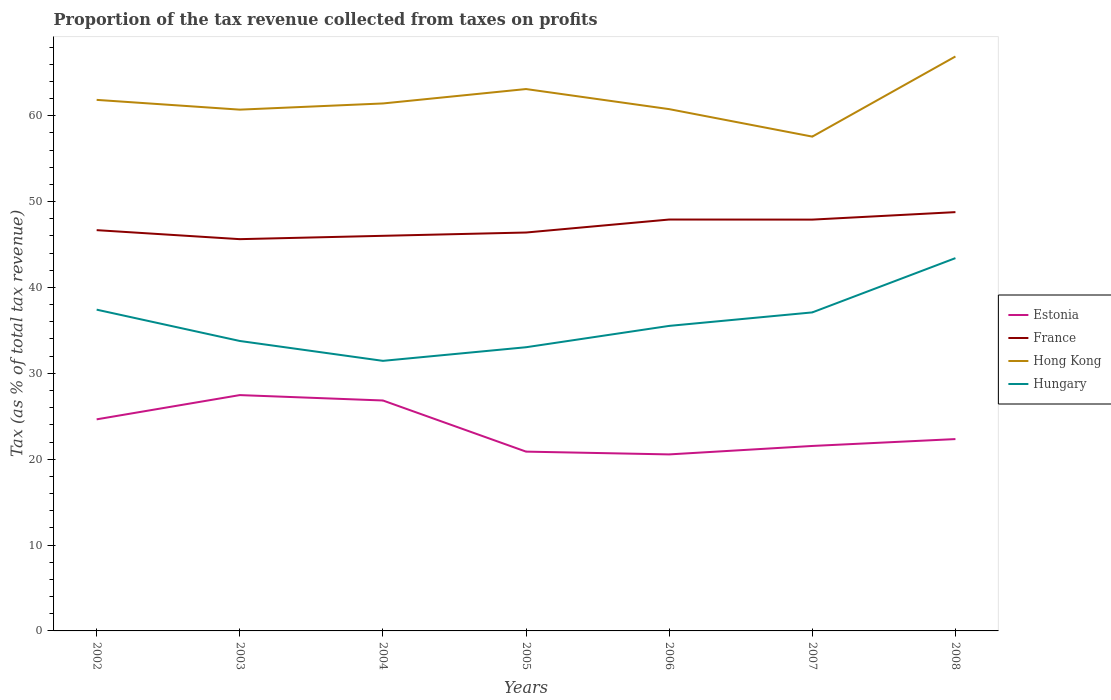How many different coloured lines are there?
Your response must be concise. 4. Across all years, what is the maximum proportion of the tax revenue collected in France?
Ensure brevity in your answer.  45.63. What is the total proportion of the tax revenue collected in Estonia in the graph?
Keep it short and to the point. 5.92. What is the difference between the highest and the second highest proportion of the tax revenue collected in Hungary?
Offer a very short reply. 11.96. Is the proportion of the tax revenue collected in Hungary strictly greater than the proportion of the tax revenue collected in France over the years?
Offer a very short reply. Yes. What is the difference between two consecutive major ticks on the Y-axis?
Provide a succinct answer. 10. Are the values on the major ticks of Y-axis written in scientific E-notation?
Make the answer very short. No. Does the graph contain any zero values?
Provide a succinct answer. No. Does the graph contain grids?
Offer a very short reply. No. Where does the legend appear in the graph?
Offer a terse response. Center right. How many legend labels are there?
Your answer should be very brief. 4. What is the title of the graph?
Your response must be concise. Proportion of the tax revenue collected from taxes on profits. Does "Ukraine" appear as one of the legend labels in the graph?
Offer a very short reply. No. What is the label or title of the X-axis?
Provide a short and direct response. Years. What is the label or title of the Y-axis?
Provide a succinct answer. Tax (as % of total tax revenue). What is the Tax (as % of total tax revenue) in Estonia in 2002?
Provide a succinct answer. 24.64. What is the Tax (as % of total tax revenue) in France in 2002?
Offer a very short reply. 46.68. What is the Tax (as % of total tax revenue) of Hong Kong in 2002?
Offer a terse response. 61.85. What is the Tax (as % of total tax revenue) in Hungary in 2002?
Your answer should be very brief. 37.42. What is the Tax (as % of total tax revenue) in Estonia in 2003?
Your answer should be very brief. 27.47. What is the Tax (as % of total tax revenue) in France in 2003?
Provide a short and direct response. 45.63. What is the Tax (as % of total tax revenue) of Hong Kong in 2003?
Provide a succinct answer. 60.71. What is the Tax (as % of total tax revenue) in Hungary in 2003?
Your answer should be compact. 33.77. What is the Tax (as % of total tax revenue) in Estonia in 2004?
Make the answer very short. 26.84. What is the Tax (as % of total tax revenue) of France in 2004?
Keep it short and to the point. 46.02. What is the Tax (as % of total tax revenue) in Hong Kong in 2004?
Your answer should be compact. 61.43. What is the Tax (as % of total tax revenue) in Hungary in 2004?
Ensure brevity in your answer.  31.45. What is the Tax (as % of total tax revenue) of Estonia in 2005?
Keep it short and to the point. 20.88. What is the Tax (as % of total tax revenue) of France in 2005?
Provide a short and direct response. 46.4. What is the Tax (as % of total tax revenue) in Hong Kong in 2005?
Provide a short and direct response. 63.11. What is the Tax (as % of total tax revenue) in Hungary in 2005?
Provide a short and direct response. 33.04. What is the Tax (as % of total tax revenue) of Estonia in 2006?
Offer a very short reply. 20.56. What is the Tax (as % of total tax revenue) of France in 2006?
Offer a very short reply. 47.91. What is the Tax (as % of total tax revenue) of Hong Kong in 2006?
Make the answer very short. 60.77. What is the Tax (as % of total tax revenue) in Hungary in 2006?
Your response must be concise. 35.53. What is the Tax (as % of total tax revenue) of Estonia in 2007?
Provide a succinct answer. 21.54. What is the Tax (as % of total tax revenue) of France in 2007?
Your answer should be compact. 47.9. What is the Tax (as % of total tax revenue) of Hong Kong in 2007?
Offer a terse response. 57.57. What is the Tax (as % of total tax revenue) of Hungary in 2007?
Offer a terse response. 37.1. What is the Tax (as % of total tax revenue) of Estonia in 2008?
Keep it short and to the point. 22.34. What is the Tax (as % of total tax revenue) of France in 2008?
Make the answer very short. 48.78. What is the Tax (as % of total tax revenue) of Hong Kong in 2008?
Offer a very short reply. 66.9. What is the Tax (as % of total tax revenue) in Hungary in 2008?
Provide a succinct answer. 43.42. Across all years, what is the maximum Tax (as % of total tax revenue) of Estonia?
Provide a succinct answer. 27.47. Across all years, what is the maximum Tax (as % of total tax revenue) in France?
Give a very brief answer. 48.78. Across all years, what is the maximum Tax (as % of total tax revenue) in Hong Kong?
Give a very brief answer. 66.9. Across all years, what is the maximum Tax (as % of total tax revenue) in Hungary?
Your response must be concise. 43.42. Across all years, what is the minimum Tax (as % of total tax revenue) in Estonia?
Your answer should be very brief. 20.56. Across all years, what is the minimum Tax (as % of total tax revenue) in France?
Keep it short and to the point. 45.63. Across all years, what is the minimum Tax (as % of total tax revenue) in Hong Kong?
Give a very brief answer. 57.57. Across all years, what is the minimum Tax (as % of total tax revenue) of Hungary?
Give a very brief answer. 31.45. What is the total Tax (as % of total tax revenue) in Estonia in the graph?
Make the answer very short. 164.27. What is the total Tax (as % of total tax revenue) of France in the graph?
Keep it short and to the point. 329.31. What is the total Tax (as % of total tax revenue) of Hong Kong in the graph?
Offer a terse response. 432.34. What is the total Tax (as % of total tax revenue) in Hungary in the graph?
Keep it short and to the point. 251.72. What is the difference between the Tax (as % of total tax revenue) in Estonia in 2002 and that in 2003?
Provide a succinct answer. -2.82. What is the difference between the Tax (as % of total tax revenue) of France in 2002 and that in 2003?
Provide a short and direct response. 1.05. What is the difference between the Tax (as % of total tax revenue) in Hong Kong in 2002 and that in 2003?
Make the answer very short. 1.14. What is the difference between the Tax (as % of total tax revenue) in Hungary in 2002 and that in 2003?
Ensure brevity in your answer.  3.65. What is the difference between the Tax (as % of total tax revenue) in Estonia in 2002 and that in 2004?
Provide a short and direct response. -2.2. What is the difference between the Tax (as % of total tax revenue) in France in 2002 and that in 2004?
Provide a short and direct response. 0.66. What is the difference between the Tax (as % of total tax revenue) of Hong Kong in 2002 and that in 2004?
Your answer should be very brief. 0.42. What is the difference between the Tax (as % of total tax revenue) in Hungary in 2002 and that in 2004?
Your response must be concise. 5.96. What is the difference between the Tax (as % of total tax revenue) of Estonia in 2002 and that in 2005?
Make the answer very short. 3.76. What is the difference between the Tax (as % of total tax revenue) of France in 2002 and that in 2005?
Give a very brief answer. 0.28. What is the difference between the Tax (as % of total tax revenue) of Hong Kong in 2002 and that in 2005?
Your answer should be very brief. -1.26. What is the difference between the Tax (as % of total tax revenue) of Hungary in 2002 and that in 2005?
Offer a terse response. 4.38. What is the difference between the Tax (as % of total tax revenue) in Estonia in 2002 and that in 2006?
Give a very brief answer. 4.08. What is the difference between the Tax (as % of total tax revenue) of France in 2002 and that in 2006?
Offer a terse response. -1.24. What is the difference between the Tax (as % of total tax revenue) in Hong Kong in 2002 and that in 2006?
Your answer should be very brief. 1.08. What is the difference between the Tax (as % of total tax revenue) in Hungary in 2002 and that in 2006?
Your response must be concise. 1.89. What is the difference between the Tax (as % of total tax revenue) in Estonia in 2002 and that in 2007?
Keep it short and to the point. 3.1. What is the difference between the Tax (as % of total tax revenue) in France in 2002 and that in 2007?
Offer a very short reply. -1.23. What is the difference between the Tax (as % of total tax revenue) in Hong Kong in 2002 and that in 2007?
Provide a short and direct response. 4.28. What is the difference between the Tax (as % of total tax revenue) of Hungary in 2002 and that in 2007?
Ensure brevity in your answer.  0.32. What is the difference between the Tax (as % of total tax revenue) of Estonia in 2002 and that in 2008?
Provide a short and direct response. 2.3. What is the difference between the Tax (as % of total tax revenue) of France in 2002 and that in 2008?
Offer a very short reply. -2.1. What is the difference between the Tax (as % of total tax revenue) of Hong Kong in 2002 and that in 2008?
Offer a terse response. -5.05. What is the difference between the Tax (as % of total tax revenue) of Hungary in 2002 and that in 2008?
Make the answer very short. -6. What is the difference between the Tax (as % of total tax revenue) in Estonia in 2003 and that in 2004?
Keep it short and to the point. 0.63. What is the difference between the Tax (as % of total tax revenue) of France in 2003 and that in 2004?
Offer a very short reply. -0.39. What is the difference between the Tax (as % of total tax revenue) in Hong Kong in 2003 and that in 2004?
Make the answer very short. -0.72. What is the difference between the Tax (as % of total tax revenue) in Hungary in 2003 and that in 2004?
Offer a very short reply. 2.32. What is the difference between the Tax (as % of total tax revenue) in Estonia in 2003 and that in 2005?
Ensure brevity in your answer.  6.58. What is the difference between the Tax (as % of total tax revenue) in France in 2003 and that in 2005?
Give a very brief answer. -0.77. What is the difference between the Tax (as % of total tax revenue) of Hong Kong in 2003 and that in 2005?
Ensure brevity in your answer.  -2.4. What is the difference between the Tax (as % of total tax revenue) in Hungary in 2003 and that in 2005?
Provide a short and direct response. 0.73. What is the difference between the Tax (as % of total tax revenue) in Estonia in 2003 and that in 2006?
Offer a terse response. 6.91. What is the difference between the Tax (as % of total tax revenue) in France in 2003 and that in 2006?
Your answer should be very brief. -2.29. What is the difference between the Tax (as % of total tax revenue) in Hong Kong in 2003 and that in 2006?
Provide a succinct answer. -0.06. What is the difference between the Tax (as % of total tax revenue) of Hungary in 2003 and that in 2006?
Ensure brevity in your answer.  -1.76. What is the difference between the Tax (as % of total tax revenue) in Estonia in 2003 and that in 2007?
Your answer should be compact. 5.92. What is the difference between the Tax (as % of total tax revenue) of France in 2003 and that in 2007?
Offer a terse response. -2.28. What is the difference between the Tax (as % of total tax revenue) of Hong Kong in 2003 and that in 2007?
Your response must be concise. 3.14. What is the difference between the Tax (as % of total tax revenue) in Hungary in 2003 and that in 2007?
Make the answer very short. -3.33. What is the difference between the Tax (as % of total tax revenue) in Estonia in 2003 and that in 2008?
Ensure brevity in your answer.  5.12. What is the difference between the Tax (as % of total tax revenue) of France in 2003 and that in 2008?
Make the answer very short. -3.15. What is the difference between the Tax (as % of total tax revenue) of Hong Kong in 2003 and that in 2008?
Make the answer very short. -6.19. What is the difference between the Tax (as % of total tax revenue) in Hungary in 2003 and that in 2008?
Provide a succinct answer. -9.65. What is the difference between the Tax (as % of total tax revenue) in Estonia in 2004 and that in 2005?
Your answer should be very brief. 5.96. What is the difference between the Tax (as % of total tax revenue) in France in 2004 and that in 2005?
Offer a very short reply. -0.38. What is the difference between the Tax (as % of total tax revenue) of Hong Kong in 2004 and that in 2005?
Your answer should be compact. -1.68. What is the difference between the Tax (as % of total tax revenue) in Hungary in 2004 and that in 2005?
Keep it short and to the point. -1.59. What is the difference between the Tax (as % of total tax revenue) of Estonia in 2004 and that in 2006?
Offer a very short reply. 6.28. What is the difference between the Tax (as % of total tax revenue) of France in 2004 and that in 2006?
Provide a succinct answer. -1.9. What is the difference between the Tax (as % of total tax revenue) in Hong Kong in 2004 and that in 2006?
Give a very brief answer. 0.66. What is the difference between the Tax (as % of total tax revenue) in Hungary in 2004 and that in 2006?
Provide a short and direct response. -4.07. What is the difference between the Tax (as % of total tax revenue) in Estonia in 2004 and that in 2007?
Provide a succinct answer. 5.3. What is the difference between the Tax (as % of total tax revenue) of France in 2004 and that in 2007?
Your answer should be compact. -1.89. What is the difference between the Tax (as % of total tax revenue) in Hong Kong in 2004 and that in 2007?
Offer a very short reply. 3.86. What is the difference between the Tax (as % of total tax revenue) of Hungary in 2004 and that in 2007?
Make the answer very short. -5.64. What is the difference between the Tax (as % of total tax revenue) of Estonia in 2004 and that in 2008?
Your answer should be very brief. 4.5. What is the difference between the Tax (as % of total tax revenue) in France in 2004 and that in 2008?
Offer a very short reply. -2.76. What is the difference between the Tax (as % of total tax revenue) of Hong Kong in 2004 and that in 2008?
Your answer should be compact. -5.47. What is the difference between the Tax (as % of total tax revenue) of Hungary in 2004 and that in 2008?
Ensure brevity in your answer.  -11.96. What is the difference between the Tax (as % of total tax revenue) of Estonia in 2005 and that in 2006?
Keep it short and to the point. 0.32. What is the difference between the Tax (as % of total tax revenue) in France in 2005 and that in 2006?
Your answer should be compact. -1.51. What is the difference between the Tax (as % of total tax revenue) in Hong Kong in 2005 and that in 2006?
Keep it short and to the point. 2.34. What is the difference between the Tax (as % of total tax revenue) of Hungary in 2005 and that in 2006?
Ensure brevity in your answer.  -2.49. What is the difference between the Tax (as % of total tax revenue) in Estonia in 2005 and that in 2007?
Provide a succinct answer. -0.66. What is the difference between the Tax (as % of total tax revenue) in France in 2005 and that in 2007?
Your answer should be compact. -1.5. What is the difference between the Tax (as % of total tax revenue) in Hong Kong in 2005 and that in 2007?
Offer a terse response. 5.54. What is the difference between the Tax (as % of total tax revenue) of Hungary in 2005 and that in 2007?
Offer a very short reply. -4.06. What is the difference between the Tax (as % of total tax revenue) in Estonia in 2005 and that in 2008?
Your answer should be compact. -1.46. What is the difference between the Tax (as % of total tax revenue) in France in 2005 and that in 2008?
Provide a succinct answer. -2.38. What is the difference between the Tax (as % of total tax revenue) in Hong Kong in 2005 and that in 2008?
Offer a very short reply. -3.79. What is the difference between the Tax (as % of total tax revenue) of Hungary in 2005 and that in 2008?
Give a very brief answer. -10.38. What is the difference between the Tax (as % of total tax revenue) in Estonia in 2006 and that in 2007?
Provide a succinct answer. -0.98. What is the difference between the Tax (as % of total tax revenue) of France in 2006 and that in 2007?
Your answer should be very brief. 0.01. What is the difference between the Tax (as % of total tax revenue) of Hong Kong in 2006 and that in 2007?
Offer a very short reply. 3.2. What is the difference between the Tax (as % of total tax revenue) of Hungary in 2006 and that in 2007?
Your answer should be very brief. -1.57. What is the difference between the Tax (as % of total tax revenue) in Estonia in 2006 and that in 2008?
Offer a terse response. -1.78. What is the difference between the Tax (as % of total tax revenue) of France in 2006 and that in 2008?
Give a very brief answer. -0.86. What is the difference between the Tax (as % of total tax revenue) of Hong Kong in 2006 and that in 2008?
Provide a succinct answer. -6.13. What is the difference between the Tax (as % of total tax revenue) in Hungary in 2006 and that in 2008?
Provide a short and direct response. -7.89. What is the difference between the Tax (as % of total tax revenue) in Estonia in 2007 and that in 2008?
Offer a very short reply. -0.8. What is the difference between the Tax (as % of total tax revenue) of France in 2007 and that in 2008?
Keep it short and to the point. -0.87. What is the difference between the Tax (as % of total tax revenue) in Hong Kong in 2007 and that in 2008?
Provide a succinct answer. -9.33. What is the difference between the Tax (as % of total tax revenue) of Hungary in 2007 and that in 2008?
Make the answer very short. -6.32. What is the difference between the Tax (as % of total tax revenue) of Estonia in 2002 and the Tax (as % of total tax revenue) of France in 2003?
Provide a succinct answer. -20.99. What is the difference between the Tax (as % of total tax revenue) in Estonia in 2002 and the Tax (as % of total tax revenue) in Hong Kong in 2003?
Make the answer very short. -36.07. What is the difference between the Tax (as % of total tax revenue) of Estonia in 2002 and the Tax (as % of total tax revenue) of Hungary in 2003?
Make the answer very short. -9.13. What is the difference between the Tax (as % of total tax revenue) of France in 2002 and the Tax (as % of total tax revenue) of Hong Kong in 2003?
Keep it short and to the point. -14.04. What is the difference between the Tax (as % of total tax revenue) in France in 2002 and the Tax (as % of total tax revenue) in Hungary in 2003?
Your answer should be compact. 12.91. What is the difference between the Tax (as % of total tax revenue) of Hong Kong in 2002 and the Tax (as % of total tax revenue) of Hungary in 2003?
Make the answer very short. 28.08. What is the difference between the Tax (as % of total tax revenue) in Estonia in 2002 and the Tax (as % of total tax revenue) in France in 2004?
Your answer should be compact. -21.37. What is the difference between the Tax (as % of total tax revenue) of Estonia in 2002 and the Tax (as % of total tax revenue) of Hong Kong in 2004?
Provide a short and direct response. -36.79. What is the difference between the Tax (as % of total tax revenue) of Estonia in 2002 and the Tax (as % of total tax revenue) of Hungary in 2004?
Keep it short and to the point. -6.81. What is the difference between the Tax (as % of total tax revenue) in France in 2002 and the Tax (as % of total tax revenue) in Hong Kong in 2004?
Your answer should be very brief. -14.76. What is the difference between the Tax (as % of total tax revenue) of France in 2002 and the Tax (as % of total tax revenue) of Hungary in 2004?
Keep it short and to the point. 15.22. What is the difference between the Tax (as % of total tax revenue) of Hong Kong in 2002 and the Tax (as % of total tax revenue) of Hungary in 2004?
Offer a very short reply. 30.4. What is the difference between the Tax (as % of total tax revenue) of Estonia in 2002 and the Tax (as % of total tax revenue) of France in 2005?
Provide a short and direct response. -21.76. What is the difference between the Tax (as % of total tax revenue) in Estonia in 2002 and the Tax (as % of total tax revenue) in Hong Kong in 2005?
Ensure brevity in your answer.  -38.47. What is the difference between the Tax (as % of total tax revenue) in Estonia in 2002 and the Tax (as % of total tax revenue) in Hungary in 2005?
Keep it short and to the point. -8.4. What is the difference between the Tax (as % of total tax revenue) of France in 2002 and the Tax (as % of total tax revenue) of Hong Kong in 2005?
Offer a very short reply. -16.43. What is the difference between the Tax (as % of total tax revenue) of France in 2002 and the Tax (as % of total tax revenue) of Hungary in 2005?
Provide a short and direct response. 13.64. What is the difference between the Tax (as % of total tax revenue) of Hong Kong in 2002 and the Tax (as % of total tax revenue) of Hungary in 2005?
Offer a terse response. 28.81. What is the difference between the Tax (as % of total tax revenue) of Estonia in 2002 and the Tax (as % of total tax revenue) of France in 2006?
Offer a very short reply. -23.27. What is the difference between the Tax (as % of total tax revenue) in Estonia in 2002 and the Tax (as % of total tax revenue) in Hong Kong in 2006?
Make the answer very short. -36.13. What is the difference between the Tax (as % of total tax revenue) in Estonia in 2002 and the Tax (as % of total tax revenue) in Hungary in 2006?
Provide a succinct answer. -10.88. What is the difference between the Tax (as % of total tax revenue) in France in 2002 and the Tax (as % of total tax revenue) in Hong Kong in 2006?
Make the answer very short. -14.09. What is the difference between the Tax (as % of total tax revenue) in France in 2002 and the Tax (as % of total tax revenue) in Hungary in 2006?
Keep it short and to the point. 11.15. What is the difference between the Tax (as % of total tax revenue) of Hong Kong in 2002 and the Tax (as % of total tax revenue) of Hungary in 2006?
Your response must be concise. 26.32. What is the difference between the Tax (as % of total tax revenue) of Estonia in 2002 and the Tax (as % of total tax revenue) of France in 2007?
Make the answer very short. -23.26. What is the difference between the Tax (as % of total tax revenue) of Estonia in 2002 and the Tax (as % of total tax revenue) of Hong Kong in 2007?
Your response must be concise. -32.93. What is the difference between the Tax (as % of total tax revenue) of Estonia in 2002 and the Tax (as % of total tax revenue) of Hungary in 2007?
Offer a very short reply. -12.46. What is the difference between the Tax (as % of total tax revenue) of France in 2002 and the Tax (as % of total tax revenue) of Hong Kong in 2007?
Make the answer very short. -10.89. What is the difference between the Tax (as % of total tax revenue) of France in 2002 and the Tax (as % of total tax revenue) of Hungary in 2007?
Give a very brief answer. 9.58. What is the difference between the Tax (as % of total tax revenue) in Hong Kong in 2002 and the Tax (as % of total tax revenue) in Hungary in 2007?
Provide a succinct answer. 24.75. What is the difference between the Tax (as % of total tax revenue) of Estonia in 2002 and the Tax (as % of total tax revenue) of France in 2008?
Keep it short and to the point. -24.13. What is the difference between the Tax (as % of total tax revenue) of Estonia in 2002 and the Tax (as % of total tax revenue) of Hong Kong in 2008?
Provide a short and direct response. -42.26. What is the difference between the Tax (as % of total tax revenue) in Estonia in 2002 and the Tax (as % of total tax revenue) in Hungary in 2008?
Offer a terse response. -18.78. What is the difference between the Tax (as % of total tax revenue) in France in 2002 and the Tax (as % of total tax revenue) in Hong Kong in 2008?
Offer a very short reply. -20.23. What is the difference between the Tax (as % of total tax revenue) in France in 2002 and the Tax (as % of total tax revenue) in Hungary in 2008?
Provide a succinct answer. 3.26. What is the difference between the Tax (as % of total tax revenue) of Hong Kong in 2002 and the Tax (as % of total tax revenue) of Hungary in 2008?
Ensure brevity in your answer.  18.43. What is the difference between the Tax (as % of total tax revenue) of Estonia in 2003 and the Tax (as % of total tax revenue) of France in 2004?
Make the answer very short. -18.55. What is the difference between the Tax (as % of total tax revenue) in Estonia in 2003 and the Tax (as % of total tax revenue) in Hong Kong in 2004?
Offer a terse response. -33.97. What is the difference between the Tax (as % of total tax revenue) in Estonia in 2003 and the Tax (as % of total tax revenue) in Hungary in 2004?
Make the answer very short. -3.99. What is the difference between the Tax (as % of total tax revenue) of France in 2003 and the Tax (as % of total tax revenue) of Hong Kong in 2004?
Your response must be concise. -15.8. What is the difference between the Tax (as % of total tax revenue) of France in 2003 and the Tax (as % of total tax revenue) of Hungary in 2004?
Offer a very short reply. 14.17. What is the difference between the Tax (as % of total tax revenue) in Hong Kong in 2003 and the Tax (as % of total tax revenue) in Hungary in 2004?
Keep it short and to the point. 29.26. What is the difference between the Tax (as % of total tax revenue) in Estonia in 2003 and the Tax (as % of total tax revenue) in France in 2005?
Provide a short and direct response. -18.93. What is the difference between the Tax (as % of total tax revenue) of Estonia in 2003 and the Tax (as % of total tax revenue) of Hong Kong in 2005?
Give a very brief answer. -35.64. What is the difference between the Tax (as % of total tax revenue) in Estonia in 2003 and the Tax (as % of total tax revenue) in Hungary in 2005?
Give a very brief answer. -5.57. What is the difference between the Tax (as % of total tax revenue) in France in 2003 and the Tax (as % of total tax revenue) in Hong Kong in 2005?
Give a very brief answer. -17.48. What is the difference between the Tax (as % of total tax revenue) in France in 2003 and the Tax (as % of total tax revenue) in Hungary in 2005?
Your answer should be very brief. 12.59. What is the difference between the Tax (as % of total tax revenue) in Hong Kong in 2003 and the Tax (as % of total tax revenue) in Hungary in 2005?
Make the answer very short. 27.67. What is the difference between the Tax (as % of total tax revenue) in Estonia in 2003 and the Tax (as % of total tax revenue) in France in 2006?
Give a very brief answer. -20.45. What is the difference between the Tax (as % of total tax revenue) in Estonia in 2003 and the Tax (as % of total tax revenue) in Hong Kong in 2006?
Provide a short and direct response. -33.3. What is the difference between the Tax (as % of total tax revenue) of Estonia in 2003 and the Tax (as % of total tax revenue) of Hungary in 2006?
Your answer should be compact. -8.06. What is the difference between the Tax (as % of total tax revenue) in France in 2003 and the Tax (as % of total tax revenue) in Hong Kong in 2006?
Make the answer very short. -15.14. What is the difference between the Tax (as % of total tax revenue) in France in 2003 and the Tax (as % of total tax revenue) in Hungary in 2006?
Keep it short and to the point. 10.1. What is the difference between the Tax (as % of total tax revenue) in Hong Kong in 2003 and the Tax (as % of total tax revenue) in Hungary in 2006?
Make the answer very short. 25.19. What is the difference between the Tax (as % of total tax revenue) of Estonia in 2003 and the Tax (as % of total tax revenue) of France in 2007?
Your answer should be very brief. -20.44. What is the difference between the Tax (as % of total tax revenue) of Estonia in 2003 and the Tax (as % of total tax revenue) of Hong Kong in 2007?
Your answer should be very brief. -30.1. What is the difference between the Tax (as % of total tax revenue) of Estonia in 2003 and the Tax (as % of total tax revenue) of Hungary in 2007?
Make the answer very short. -9.63. What is the difference between the Tax (as % of total tax revenue) of France in 2003 and the Tax (as % of total tax revenue) of Hong Kong in 2007?
Offer a very short reply. -11.94. What is the difference between the Tax (as % of total tax revenue) in France in 2003 and the Tax (as % of total tax revenue) in Hungary in 2007?
Offer a very short reply. 8.53. What is the difference between the Tax (as % of total tax revenue) of Hong Kong in 2003 and the Tax (as % of total tax revenue) of Hungary in 2007?
Provide a short and direct response. 23.61. What is the difference between the Tax (as % of total tax revenue) of Estonia in 2003 and the Tax (as % of total tax revenue) of France in 2008?
Offer a very short reply. -21.31. What is the difference between the Tax (as % of total tax revenue) in Estonia in 2003 and the Tax (as % of total tax revenue) in Hong Kong in 2008?
Your answer should be very brief. -39.44. What is the difference between the Tax (as % of total tax revenue) of Estonia in 2003 and the Tax (as % of total tax revenue) of Hungary in 2008?
Make the answer very short. -15.95. What is the difference between the Tax (as % of total tax revenue) of France in 2003 and the Tax (as % of total tax revenue) of Hong Kong in 2008?
Your response must be concise. -21.28. What is the difference between the Tax (as % of total tax revenue) of France in 2003 and the Tax (as % of total tax revenue) of Hungary in 2008?
Your answer should be very brief. 2.21. What is the difference between the Tax (as % of total tax revenue) of Hong Kong in 2003 and the Tax (as % of total tax revenue) of Hungary in 2008?
Provide a succinct answer. 17.29. What is the difference between the Tax (as % of total tax revenue) of Estonia in 2004 and the Tax (as % of total tax revenue) of France in 2005?
Offer a very short reply. -19.56. What is the difference between the Tax (as % of total tax revenue) in Estonia in 2004 and the Tax (as % of total tax revenue) in Hong Kong in 2005?
Keep it short and to the point. -36.27. What is the difference between the Tax (as % of total tax revenue) in Estonia in 2004 and the Tax (as % of total tax revenue) in Hungary in 2005?
Provide a short and direct response. -6.2. What is the difference between the Tax (as % of total tax revenue) in France in 2004 and the Tax (as % of total tax revenue) in Hong Kong in 2005?
Your answer should be very brief. -17.09. What is the difference between the Tax (as % of total tax revenue) in France in 2004 and the Tax (as % of total tax revenue) in Hungary in 2005?
Ensure brevity in your answer.  12.98. What is the difference between the Tax (as % of total tax revenue) of Hong Kong in 2004 and the Tax (as % of total tax revenue) of Hungary in 2005?
Make the answer very short. 28.39. What is the difference between the Tax (as % of total tax revenue) of Estonia in 2004 and the Tax (as % of total tax revenue) of France in 2006?
Your answer should be compact. -21.08. What is the difference between the Tax (as % of total tax revenue) of Estonia in 2004 and the Tax (as % of total tax revenue) of Hong Kong in 2006?
Ensure brevity in your answer.  -33.93. What is the difference between the Tax (as % of total tax revenue) of Estonia in 2004 and the Tax (as % of total tax revenue) of Hungary in 2006?
Your answer should be compact. -8.69. What is the difference between the Tax (as % of total tax revenue) in France in 2004 and the Tax (as % of total tax revenue) in Hong Kong in 2006?
Offer a very short reply. -14.75. What is the difference between the Tax (as % of total tax revenue) of France in 2004 and the Tax (as % of total tax revenue) of Hungary in 2006?
Your answer should be very brief. 10.49. What is the difference between the Tax (as % of total tax revenue) in Hong Kong in 2004 and the Tax (as % of total tax revenue) in Hungary in 2006?
Give a very brief answer. 25.91. What is the difference between the Tax (as % of total tax revenue) in Estonia in 2004 and the Tax (as % of total tax revenue) in France in 2007?
Keep it short and to the point. -21.07. What is the difference between the Tax (as % of total tax revenue) in Estonia in 2004 and the Tax (as % of total tax revenue) in Hong Kong in 2007?
Keep it short and to the point. -30.73. What is the difference between the Tax (as % of total tax revenue) of Estonia in 2004 and the Tax (as % of total tax revenue) of Hungary in 2007?
Keep it short and to the point. -10.26. What is the difference between the Tax (as % of total tax revenue) in France in 2004 and the Tax (as % of total tax revenue) in Hong Kong in 2007?
Offer a very short reply. -11.55. What is the difference between the Tax (as % of total tax revenue) of France in 2004 and the Tax (as % of total tax revenue) of Hungary in 2007?
Ensure brevity in your answer.  8.92. What is the difference between the Tax (as % of total tax revenue) in Hong Kong in 2004 and the Tax (as % of total tax revenue) in Hungary in 2007?
Give a very brief answer. 24.33. What is the difference between the Tax (as % of total tax revenue) in Estonia in 2004 and the Tax (as % of total tax revenue) in France in 2008?
Ensure brevity in your answer.  -21.94. What is the difference between the Tax (as % of total tax revenue) of Estonia in 2004 and the Tax (as % of total tax revenue) of Hong Kong in 2008?
Offer a very short reply. -40.07. What is the difference between the Tax (as % of total tax revenue) of Estonia in 2004 and the Tax (as % of total tax revenue) of Hungary in 2008?
Offer a terse response. -16.58. What is the difference between the Tax (as % of total tax revenue) of France in 2004 and the Tax (as % of total tax revenue) of Hong Kong in 2008?
Provide a succinct answer. -20.89. What is the difference between the Tax (as % of total tax revenue) in France in 2004 and the Tax (as % of total tax revenue) in Hungary in 2008?
Give a very brief answer. 2.6. What is the difference between the Tax (as % of total tax revenue) in Hong Kong in 2004 and the Tax (as % of total tax revenue) in Hungary in 2008?
Provide a short and direct response. 18.01. What is the difference between the Tax (as % of total tax revenue) in Estonia in 2005 and the Tax (as % of total tax revenue) in France in 2006?
Offer a very short reply. -27.03. What is the difference between the Tax (as % of total tax revenue) in Estonia in 2005 and the Tax (as % of total tax revenue) in Hong Kong in 2006?
Provide a short and direct response. -39.89. What is the difference between the Tax (as % of total tax revenue) in Estonia in 2005 and the Tax (as % of total tax revenue) in Hungary in 2006?
Your answer should be compact. -14.64. What is the difference between the Tax (as % of total tax revenue) in France in 2005 and the Tax (as % of total tax revenue) in Hong Kong in 2006?
Ensure brevity in your answer.  -14.37. What is the difference between the Tax (as % of total tax revenue) of France in 2005 and the Tax (as % of total tax revenue) of Hungary in 2006?
Provide a short and direct response. 10.87. What is the difference between the Tax (as % of total tax revenue) in Hong Kong in 2005 and the Tax (as % of total tax revenue) in Hungary in 2006?
Offer a terse response. 27.58. What is the difference between the Tax (as % of total tax revenue) in Estonia in 2005 and the Tax (as % of total tax revenue) in France in 2007?
Provide a short and direct response. -27.02. What is the difference between the Tax (as % of total tax revenue) of Estonia in 2005 and the Tax (as % of total tax revenue) of Hong Kong in 2007?
Keep it short and to the point. -36.69. What is the difference between the Tax (as % of total tax revenue) in Estonia in 2005 and the Tax (as % of total tax revenue) in Hungary in 2007?
Keep it short and to the point. -16.21. What is the difference between the Tax (as % of total tax revenue) in France in 2005 and the Tax (as % of total tax revenue) in Hong Kong in 2007?
Keep it short and to the point. -11.17. What is the difference between the Tax (as % of total tax revenue) of France in 2005 and the Tax (as % of total tax revenue) of Hungary in 2007?
Your answer should be very brief. 9.3. What is the difference between the Tax (as % of total tax revenue) in Hong Kong in 2005 and the Tax (as % of total tax revenue) in Hungary in 2007?
Make the answer very short. 26.01. What is the difference between the Tax (as % of total tax revenue) in Estonia in 2005 and the Tax (as % of total tax revenue) in France in 2008?
Provide a short and direct response. -27.89. What is the difference between the Tax (as % of total tax revenue) of Estonia in 2005 and the Tax (as % of total tax revenue) of Hong Kong in 2008?
Keep it short and to the point. -46.02. What is the difference between the Tax (as % of total tax revenue) in Estonia in 2005 and the Tax (as % of total tax revenue) in Hungary in 2008?
Offer a very short reply. -22.53. What is the difference between the Tax (as % of total tax revenue) in France in 2005 and the Tax (as % of total tax revenue) in Hong Kong in 2008?
Provide a succinct answer. -20.5. What is the difference between the Tax (as % of total tax revenue) in France in 2005 and the Tax (as % of total tax revenue) in Hungary in 2008?
Your response must be concise. 2.98. What is the difference between the Tax (as % of total tax revenue) of Hong Kong in 2005 and the Tax (as % of total tax revenue) of Hungary in 2008?
Provide a succinct answer. 19.69. What is the difference between the Tax (as % of total tax revenue) of Estonia in 2006 and the Tax (as % of total tax revenue) of France in 2007?
Keep it short and to the point. -27.34. What is the difference between the Tax (as % of total tax revenue) of Estonia in 2006 and the Tax (as % of total tax revenue) of Hong Kong in 2007?
Offer a terse response. -37.01. What is the difference between the Tax (as % of total tax revenue) of Estonia in 2006 and the Tax (as % of total tax revenue) of Hungary in 2007?
Your response must be concise. -16.54. What is the difference between the Tax (as % of total tax revenue) of France in 2006 and the Tax (as % of total tax revenue) of Hong Kong in 2007?
Make the answer very short. -9.66. What is the difference between the Tax (as % of total tax revenue) of France in 2006 and the Tax (as % of total tax revenue) of Hungary in 2007?
Your answer should be very brief. 10.82. What is the difference between the Tax (as % of total tax revenue) in Hong Kong in 2006 and the Tax (as % of total tax revenue) in Hungary in 2007?
Keep it short and to the point. 23.67. What is the difference between the Tax (as % of total tax revenue) of Estonia in 2006 and the Tax (as % of total tax revenue) of France in 2008?
Provide a short and direct response. -28.22. What is the difference between the Tax (as % of total tax revenue) in Estonia in 2006 and the Tax (as % of total tax revenue) in Hong Kong in 2008?
Your response must be concise. -46.35. What is the difference between the Tax (as % of total tax revenue) in Estonia in 2006 and the Tax (as % of total tax revenue) in Hungary in 2008?
Keep it short and to the point. -22.86. What is the difference between the Tax (as % of total tax revenue) of France in 2006 and the Tax (as % of total tax revenue) of Hong Kong in 2008?
Keep it short and to the point. -18.99. What is the difference between the Tax (as % of total tax revenue) in France in 2006 and the Tax (as % of total tax revenue) in Hungary in 2008?
Offer a terse response. 4.5. What is the difference between the Tax (as % of total tax revenue) in Hong Kong in 2006 and the Tax (as % of total tax revenue) in Hungary in 2008?
Your response must be concise. 17.35. What is the difference between the Tax (as % of total tax revenue) of Estonia in 2007 and the Tax (as % of total tax revenue) of France in 2008?
Your answer should be compact. -27.23. What is the difference between the Tax (as % of total tax revenue) in Estonia in 2007 and the Tax (as % of total tax revenue) in Hong Kong in 2008?
Give a very brief answer. -45.36. What is the difference between the Tax (as % of total tax revenue) in Estonia in 2007 and the Tax (as % of total tax revenue) in Hungary in 2008?
Give a very brief answer. -21.88. What is the difference between the Tax (as % of total tax revenue) of France in 2007 and the Tax (as % of total tax revenue) of Hong Kong in 2008?
Your response must be concise. -19. What is the difference between the Tax (as % of total tax revenue) in France in 2007 and the Tax (as % of total tax revenue) in Hungary in 2008?
Offer a very short reply. 4.49. What is the difference between the Tax (as % of total tax revenue) of Hong Kong in 2007 and the Tax (as % of total tax revenue) of Hungary in 2008?
Offer a terse response. 14.15. What is the average Tax (as % of total tax revenue) of Estonia per year?
Your response must be concise. 23.47. What is the average Tax (as % of total tax revenue) in France per year?
Give a very brief answer. 47.04. What is the average Tax (as % of total tax revenue) in Hong Kong per year?
Give a very brief answer. 61.76. What is the average Tax (as % of total tax revenue) of Hungary per year?
Provide a succinct answer. 35.96. In the year 2002, what is the difference between the Tax (as % of total tax revenue) in Estonia and Tax (as % of total tax revenue) in France?
Ensure brevity in your answer.  -22.04. In the year 2002, what is the difference between the Tax (as % of total tax revenue) of Estonia and Tax (as % of total tax revenue) of Hong Kong?
Provide a short and direct response. -37.21. In the year 2002, what is the difference between the Tax (as % of total tax revenue) of Estonia and Tax (as % of total tax revenue) of Hungary?
Your answer should be compact. -12.78. In the year 2002, what is the difference between the Tax (as % of total tax revenue) in France and Tax (as % of total tax revenue) in Hong Kong?
Your response must be concise. -15.17. In the year 2002, what is the difference between the Tax (as % of total tax revenue) of France and Tax (as % of total tax revenue) of Hungary?
Offer a terse response. 9.26. In the year 2002, what is the difference between the Tax (as % of total tax revenue) in Hong Kong and Tax (as % of total tax revenue) in Hungary?
Keep it short and to the point. 24.43. In the year 2003, what is the difference between the Tax (as % of total tax revenue) in Estonia and Tax (as % of total tax revenue) in France?
Give a very brief answer. -18.16. In the year 2003, what is the difference between the Tax (as % of total tax revenue) of Estonia and Tax (as % of total tax revenue) of Hong Kong?
Provide a succinct answer. -33.25. In the year 2003, what is the difference between the Tax (as % of total tax revenue) of Estonia and Tax (as % of total tax revenue) of Hungary?
Offer a terse response. -6.3. In the year 2003, what is the difference between the Tax (as % of total tax revenue) of France and Tax (as % of total tax revenue) of Hong Kong?
Make the answer very short. -15.08. In the year 2003, what is the difference between the Tax (as % of total tax revenue) in France and Tax (as % of total tax revenue) in Hungary?
Give a very brief answer. 11.86. In the year 2003, what is the difference between the Tax (as % of total tax revenue) of Hong Kong and Tax (as % of total tax revenue) of Hungary?
Offer a very short reply. 26.94. In the year 2004, what is the difference between the Tax (as % of total tax revenue) of Estonia and Tax (as % of total tax revenue) of France?
Make the answer very short. -19.18. In the year 2004, what is the difference between the Tax (as % of total tax revenue) in Estonia and Tax (as % of total tax revenue) in Hong Kong?
Provide a succinct answer. -34.59. In the year 2004, what is the difference between the Tax (as % of total tax revenue) in Estonia and Tax (as % of total tax revenue) in Hungary?
Keep it short and to the point. -4.62. In the year 2004, what is the difference between the Tax (as % of total tax revenue) in France and Tax (as % of total tax revenue) in Hong Kong?
Offer a terse response. -15.42. In the year 2004, what is the difference between the Tax (as % of total tax revenue) of France and Tax (as % of total tax revenue) of Hungary?
Offer a very short reply. 14.56. In the year 2004, what is the difference between the Tax (as % of total tax revenue) in Hong Kong and Tax (as % of total tax revenue) in Hungary?
Your response must be concise. 29.98. In the year 2005, what is the difference between the Tax (as % of total tax revenue) in Estonia and Tax (as % of total tax revenue) in France?
Provide a short and direct response. -25.52. In the year 2005, what is the difference between the Tax (as % of total tax revenue) of Estonia and Tax (as % of total tax revenue) of Hong Kong?
Provide a short and direct response. -42.23. In the year 2005, what is the difference between the Tax (as % of total tax revenue) of Estonia and Tax (as % of total tax revenue) of Hungary?
Make the answer very short. -12.16. In the year 2005, what is the difference between the Tax (as % of total tax revenue) in France and Tax (as % of total tax revenue) in Hong Kong?
Offer a very short reply. -16.71. In the year 2005, what is the difference between the Tax (as % of total tax revenue) in France and Tax (as % of total tax revenue) in Hungary?
Provide a short and direct response. 13.36. In the year 2005, what is the difference between the Tax (as % of total tax revenue) in Hong Kong and Tax (as % of total tax revenue) in Hungary?
Offer a very short reply. 30.07. In the year 2006, what is the difference between the Tax (as % of total tax revenue) of Estonia and Tax (as % of total tax revenue) of France?
Offer a terse response. -27.35. In the year 2006, what is the difference between the Tax (as % of total tax revenue) of Estonia and Tax (as % of total tax revenue) of Hong Kong?
Your response must be concise. -40.21. In the year 2006, what is the difference between the Tax (as % of total tax revenue) of Estonia and Tax (as % of total tax revenue) of Hungary?
Your answer should be very brief. -14.97. In the year 2006, what is the difference between the Tax (as % of total tax revenue) of France and Tax (as % of total tax revenue) of Hong Kong?
Offer a very short reply. -12.86. In the year 2006, what is the difference between the Tax (as % of total tax revenue) of France and Tax (as % of total tax revenue) of Hungary?
Your answer should be very brief. 12.39. In the year 2006, what is the difference between the Tax (as % of total tax revenue) of Hong Kong and Tax (as % of total tax revenue) of Hungary?
Offer a terse response. 25.25. In the year 2007, what is the difference between the Tax (as % of total tax revenue) in Estonia and Tax (as % of total tax revenue) in France?
Your answer should be very brief. -26.36. In the year 2007, what is the difference between the Tax (as % of total tax revenue) in Estonia and Tax (as % of total tax revenue) in Hong Kong?
Make the answer very short. -36.03. In the year 2007, what is the difference between the Tax (as % of total tax revenue) of Estonia and Tax (as % of total tax revenue) of Hungary?
Your answer should be compact. -15.55. In the year 2007, what is the difference between the Tax (as % of total tax revenue) in France and Tax (as % of total tax revenue) in Hong Kong?
Offer a very short reply. -9.67. In the year 2007, what is the difference between the Tax (as % of total tax revenue) of France and Tax (as % of total tax revenue) of Hungary?
Give a very brief answer. 10.81. In the year 2007, what is the difference between the Tax (as % of total tax revenue) of Hong Kong and Tax (as % of total tax revenue) of Hungary?
Provide a succinct answer. 20.47. In the year 2008, what is the difference between the Tax (as % of total tax revenue) of Estonia and Tax (as % of total tax revenue) of France?
Offer a terse response. -26.43. In the year 2008, what is the difference between the Tax (as % of total tax revenue) of Estonia and Tax (as % of total tax revenue) of Hong Kong?
Offer a very short reply. -44.56. In the year 2008, what is the difference between the Tax (as % of total tax revenue) of Estonia and Tax (as % of total tax revenue) of Hungary?
Provide a short and direct response. -21.08. In the year 2008, what is the difference between the Tax (as % of total tax revenue) of France and Tax (as % of total tax revenue) of Hong Kong?
Provide a succinct answer. -18.13. In the year 2008, what is the difference between the Tax (as % of total tax revenue) of France and Tax (as % of total tax revenue) of Hungary?
Provide a succinct answer. 5.36. In the year 2008, what is the difference between the Tax (as % of total tax revenue) in Hong Kong and Tax (as % of total tax revenue) in Hungary?
Your response must be concise. 23.49. What is the ratio of the Tax (as % of total tax revenue) of Estonia in 2002 to that in 2003?
Offer a terse response. 0.9. What is the ratio of the Tax (as % of total tax revenue) in France in 2002 to that in 2003?
Provide a short and direct response. 1.02. What is the ratio of the Tax (as % of total tax revenue) of Hong Kong in 2002 to that in 2003?
Provide a succinct answer. 1.02. What is the ratio of the Tax (as % of total tax revenue) in Hungary in 2002 to that in 2003?
Offer a terse response. 1.11. What is the ratio of the Tax (as % of total tax revenue) in Estonia in 2002 to that in 2004?
Your answer should be very brief. 0.92. What is the ratio of the Tax (as % of total tax revenue) of France in 2002 to that in 2004?
Provide a short and direct response. 1.01. What is the ratio of the Tax (as % of total tax revenue) of Hong Kong in 2002 to that in 2004?
Keep it short and to the point. 1.01. What is the ratio of the Tax (as % of total tax revenue) of Hungary in 2002 to that in 2004?
Offer a very short reply. 1.19. What is the ratio of the Tax (as % of total tax revenue) of Estonia in 2002 to that in 2005?
Keep it short and to the point. 1.18. What is the ratio of the Tax (as % of total tax revenue) of Hong Kong in 2002 to that in 2005?
Your answer should be compact. 0.98. What is the ratio of the Tax (as % of total tax revenue) of Hungary in 2002 to that in 2005?
Your answer should be compact. 1.13. What is the ratio of the Tax (as % of total tax revenue) of Estonia in 2002 to that in 2006?
Ensure brevity in your answer.  1.2. What is the ratio of the Tax (as % of total tax revenue) in France in 2002 to that in 2006?
Make the answer very short. 0.97. What is the ratio of the Tax (as % of total tax revenue) in Hong Kong in 2002 to that in 2006?
Keep it short and to the point. 1.02. What is the ratio of the Tax (as % of total tax revenue) of Hungary in 2002 to that in 2006?
Your response must be concise. 1.05. What is the ratio of the Tax (as % of total tax revenue) in Estonia in 2002 to that in 2007?
Provide a succinct answer. 1.14. What is the ratio of the Tax (as % of total tax revenue) of France in 2002 to that in 2007?
Keep it short and to the point. 0.97. What is the ratio of the Tax (as % of total tax revenue) in Hong Kong in 2002 to that in 2007?
Provide a succinct answer. 1.07. What is the ratio of the Tax (as % of total tax revenue) in Hungary in 2002 to that in 2007?
Provide a succinct answer. 1.01. What is the ratio of the Tax (as % of total tax revenue) in Estonia in 2002 to that in 2008?
Give a very brief answer. 1.1. What is the ratio of the Tax (as % of total tax revenue) of Hong Kong in 2002 to that in 2008?
Ensure brevity in your answer.  0.92. What is the ratio of the Tax (as % of total tax revenue) in Hungary in 2002 to that in 2008?
Make the answer very short. 0.86. What is the ratio of the Tax (as % of total tax revenue) in Estonia in 2003 to that in 2004?
Your response must be concise. 1.02. What is the ratio of the Tax (as % of total tax revenue) of Hong Kong in 2003 to that in 2004?
Offer a very short reply. 0.99. What is the ratio of the Tax (as % of total tax revenue) in Hungary in 2003 to that in 2004?
Ensure brevity in your answer.  1.07. What is the ratio of the Tax (as % of total tax revenue) in Estonia in 2003 to that in 2005?
Your answer should be very brief. 1.32. What is the ratio of the Tax (as % of total tax revenue) of France in 2003 to that in 2005?
Make the answer very short. 0.98. What is the ratio of the Tax (as % of total tax revenue) in Hong Kong in 2003 to that in 2005?
Offer a very short reply. 0.96. What is the ratio of the Tax (as % of total tax revenue) in Hungary in 2003 to that in 2005?
Your response must be concise. 1.02. What is the ratio of the Tax (as % of total tax revenue) in Estonia in 2003 to that in 2006?
Your answer should be compact. 1.34. What is the ratio of the Tax (as % of total tax revenue) of France in 2003 to that in 2006?
Offer a terse response. 0.95. What is the ratio of the Tax (as % of total tax revenue) of Hong Kong in 2003 to that in 2006?
Keep it short and to the point. 1. What is the ratio of the Tax (as % of total tax revenue) in Hungary in 2003 to that in 2006?
Ensure brevity in your answer.  0.95. What is the ratio of the Tax (as % of total tax revenue) in Estonia in 2003 to that in 2007?
Make the answer very short. 1.27. What is the ratio of the Tax (as % of total tax revenue) in France in 2003 to that in 2007?
Make the answer very short. 0.95. What is the ratio of the Tax (as % of total tax revenue) of Hong Kong in 2003 to that in 2007?
Make the answer very short. 1.05. What is the ratio of the Tax (as % of total tax revenue) of Hungary in 2003 to that in 2007?
Provide a short and direct response. 0.91. What is the ratio of the Tax (as % of total tax revenue) of Estonia in 2003 to that in 2008?
Your answer should be very brief. 1.23. What is the ratio of the Tax (as % of total tax revenue) of France in 2003 to that in 2008?
Offer a very short reply. 0.94. What is the ratio of the Tax (as % of total tax revenue) in Hong Kong in 2003 to that in 2008?
Offer a terse response. 0.91. What is the ratio of the Tax (as % of total tax revenue) in Estonia in 2004 to that in 2005?
Make the answer very short. 1.29. What is the ratio of the Tax (as % of total tax revenue) of Hong Kong in 2004 to that in 2005?
Give a very brief answer. 0.97. What is the ratio of the Tax (as % of total tax revenue) of Estonia in 2004 to that in 2006?
Give a very brief answer. 1.31. What is the ratio of the Tax (as % of total tax revenue) in France in 2004 to that in 2006?
Ensure brevity in your answer.  0.96. What is the ratio of the Tax (as % of total tax revenue) of Hong Kong in 2004 to that in 2006?
Ensure brevity in your answer.  1.01. What is the ratio of the Tax (as % of total tax revenue) in Hungary in 2004 to that in 2006?
Make the answer very short. 0.89. What is the ratio of the Tax (as % of total tax revenue) of Estonia in 2004 to that in 2007?
Your response must be concise. 1.25. What is the ratio of the Tax (as % of total tax revenue) of France in 2004 to that in 2007?
Offer a terse response. 0.96. What is the ratio of the Tax (as % of total tax revenue) in Hong Kong in 2004 to that in 2007?
Your response must be concise. 1.07. What is the ratio of the Tax (as % of total tax revenue) of Hungary in 2004 to that in 2007?
Give a very brief answer. 0.85. What is the ratio of the Tax (as % of total tax revenue) of Estonia in 2004 to that in 2008?
Give a very brief answer. 1.2. What is the ratio of the Tax (as % of total tax revenue) of France in 2004 to that in 2008?
Your answer should be very brief. 0.94. What is the ratio of the Tax (as % of total tax revenue) of Hong Kong in 2004 to that in 2008?
Offer a very short reply. 0.92. What is the ratio of the Tax (as % of total tax revenue) of Hungary in 2004 to that in 2008?
Your response must be concise. 0.72. What is the ratio of the Tax (as % of total tax revenue) in Estonia in 2005 to that in 2006?
Your answer should be very brief. 1.02. What is the ratio of the Tax (as % of total tax revenue) of France in 2005 to that in 2006?
Provide a succinct answer. 0.97. What is the ratio of the Tax (as % of total tax revenue) of Hong Kong in 2005 to that in 2006?
Provide a short and direct response. 1.04. What is the ratio of the Tax (as % of total tax revenue) of Estonia in 2005 to that in 2007?
Provide a short and direct response. 0.97. What is the ratio of the Tax (as % of total tax revenue) in France in 2005 to that in 2007?
Give a very brief answer. 0.97. What is the ratio of the Tax (as % of total tax revenue) of Hong Kong in 2005 to that in 2007?
Your response must be concise. 1.1. What is the ratio of the Tax (as % of total tax revenue) in Hungary in 2005 to that in 2007?
Your answer should be compact. 0.89. What is the ratio of the Tax (as % of total tax revenue) in Estonia in 2005 to that in 2008?
Your answer should be very brief. 0.93. What is the ratio of the Tax (as % of total tax revenue) in France in 2005 to that in 2008?
Keep it short and to the point. 0.95. What is the ratio of the Tax (as % of total tax revenue) of Hong Kong in 2005 to that in 2008?
Your response must be concise. 0.94. What is the ratio of the Tax (as % of total tax revenue) in Hungary in 2005 to that in 2008?
Your answer should be compact. 0.76. What is the ratio of the Tax (as % of total tax revenue) of Estonia in 2006 to that in 2007?
Keep it short and to the point. 0.95. What is the ratio of the Tax (as % of total tax revenue) of France in 2006 to that in 2007?
Provide a succinct answer. 1. What is the ratio of the Tax (as % of total tax revenue) of Hong Kong in 2006 to that in 2007?
Your response must be concise. 1.06. What is the ratio of the Tax (as % of total tax revenue) in Hungary in 2006 to that in 2007?
Offer a very short reply. 0.96. What is the ratio of the Tax (as % of total tax revenue) of Estonia in 2006 to that in 2008?
Your answer should be very brief. 0.92. What is the ratio of the Tax (as % of total tax revenue) of France in 2006 to that in 2008?
Your answer should be very brief. 0.98. What is the ratio of the Tax (as % of total tax revenue) in Hong Kong in 2006 to that in 2008?
Keep it short and to the point. 0.91. What is the ratio of the Tax (as % of total tax revenue) in Hungary in 2006 to that in 2008?
Offer a terse response. 0.82. What is the ratio of the Tax (as % of total tax revenue) in Estonia in 2007 to that in 2008?
Make the answer very short. 0.96. What is the ratio of the Tax (as % of total tax revenue) of France in 2007 to that in 2008?
Make the answer very short. 0.98. What is the ratio of the Tax (as % of total tax revenue) in Hong Kong in 2007 to that in 2008?
Provide a short and direct response. 0.86. What is the ratio of the Tax (as % of total tax revenue) of Hungary in 2007 to that in 2008?
Offer a very short reply. 0.85. What is the difference between the highest and the second highest Tax (as % of total tax revenue) in Estonia?
Provide a succinct answer. 0.63. What is the difference between the highest and the second highest Tax (as % of total tax revenue) of France?
Offer a terse response. 0.86. What is the difference between the highest and the second highest Tax (as % of total tax revenue) of Hong Kong?
Provide a short and direct response. 3.79. What is the difference between the highest and the second highest Tax (as % of total tax revenue) of Hungary?
Keep it short and to the point. 6. What is the difference between the highest and the lowest Tax (as % of total tax revenue) of Estonia?
Ensure brevity in your answer.  6.91. What is the difference between the highest and the lowest Tax (as % of total tax revenue) of France?
Provide a succinct answer. 3.15. What is the difference between the highest and the lowest Tax (as % of total tax revenue) in Hong Kong?
Provide a short and direct response. 9.33. What is the difference between the highest and the lowest Tax (as % of total tax revenue) of Hungary?
Offer a very short reply. 11.96. 